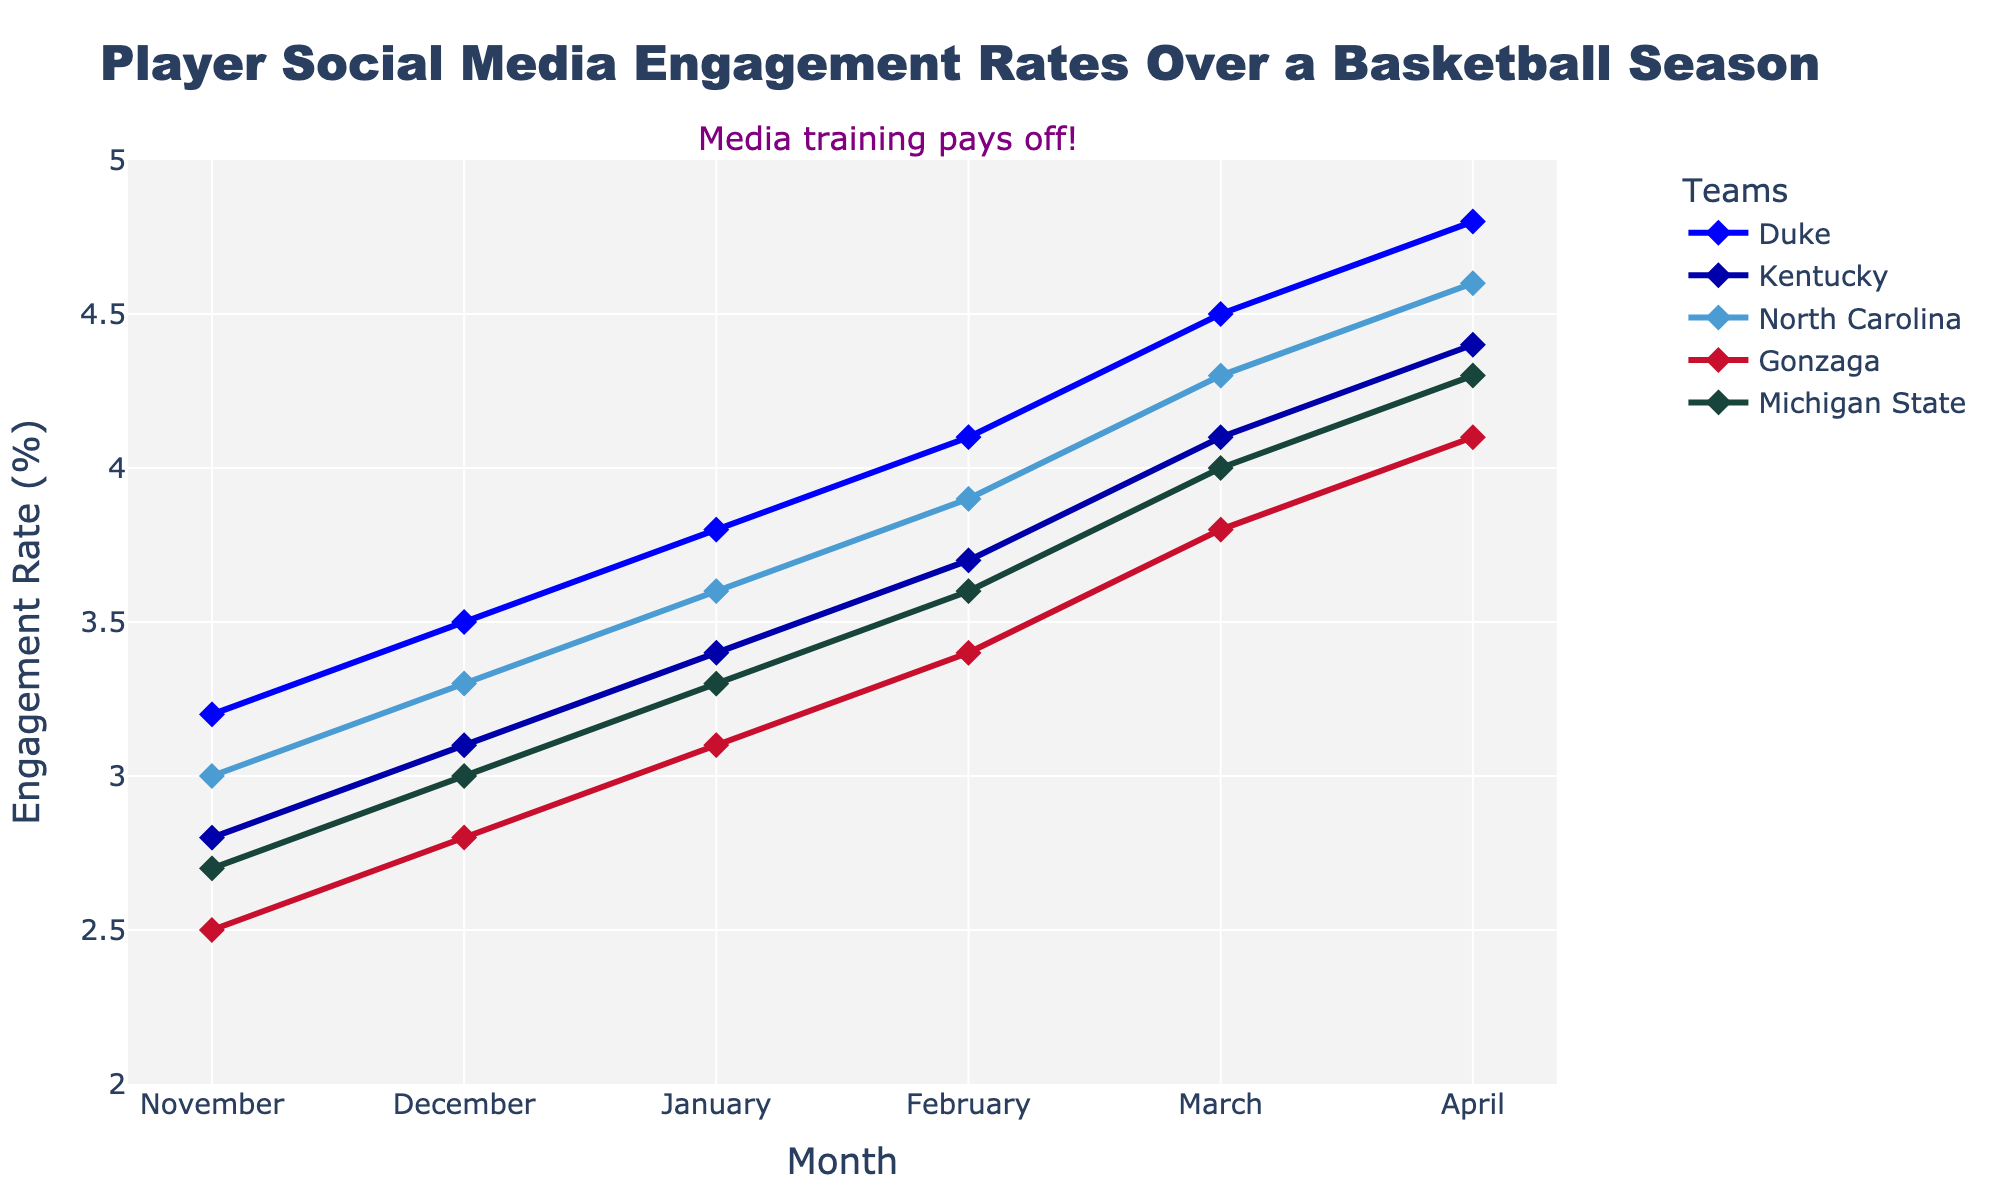What's the trend of Duke's engagement rate over the months? Duke's engagement rate starts at 3.2 in November and gradually increases each month, reaching 4.8 in April.
Answer: It shows an increasing trend Which team had the lowest engagement rate in February? In February, Gonzaga's engagement rate is the lowest among the teams with a value of 3.4.
Answer: Gonzaga By how much did Duke's engagement rate increase from November to April? The engagement rate for Duke increased from 3.2 in November to 4.8 in April. The difference is 4.8 - 3.2 = 1.6.
Answer: 1.6 In which month did Kentucky surpass North Carolina in engagement rate for the first time? By comparing the monthly engagement rates, Kentucky surpassed North Carolina for the first time in March.
Answer: March What is the average engagement rate for Michigan State over the season? The engagement rates for Michigan State are 2.7, 3.0, 3.3, 3.6, 4.0, and 4.3. The sum is 20.9 and the average is 20.9/6 = 3.48.
Answer: 3.48 Which team had the most significant increase in engagement rate from November to April? By calculating the difference from November to April for each team, Duke had the most significant increase (4.8 - 3.2 = 1.6).
Answer: Duke Is there any month where all teams had an engagement rate above 3? By checking each month's engagement rates, December onwards shows all teams having engagement rates above 3.
Answer: December onwards Compare the engagement rates of Gonzaga and Michigan State in April. Which team had a higher rate, and by how much? In April, Gonzaga had an engagement rate of 4.1, and Michigan State had 4.3. Michigan State's rate was higher by 4.3 - 4.1 = 0.2.
Answer: Michigan State by 0.2 What was the combined engagement rate for North Carolina and Gonzaga in January? North Carolina had an engagement rate of 3.6 and Gonzaga had 3.1 in January. The combined total is 3.6 + 3.1 = 6.7.
Answer: 6.7 For February, rank the teams based on their engagement rates from highest to lowest. The engagement rates in February are Duke (4.1), North Carolina (3.9), Kentucky (3.7), Michigan State (3.6), and Gonzaga (3.4). The ranking from highest to lowest is Duke, North Carolina, Kentucky, Michigan State, and Gonzaga.
Answer: Duke > North Carolina > Kentucky > Michigan State > Gonzaga 